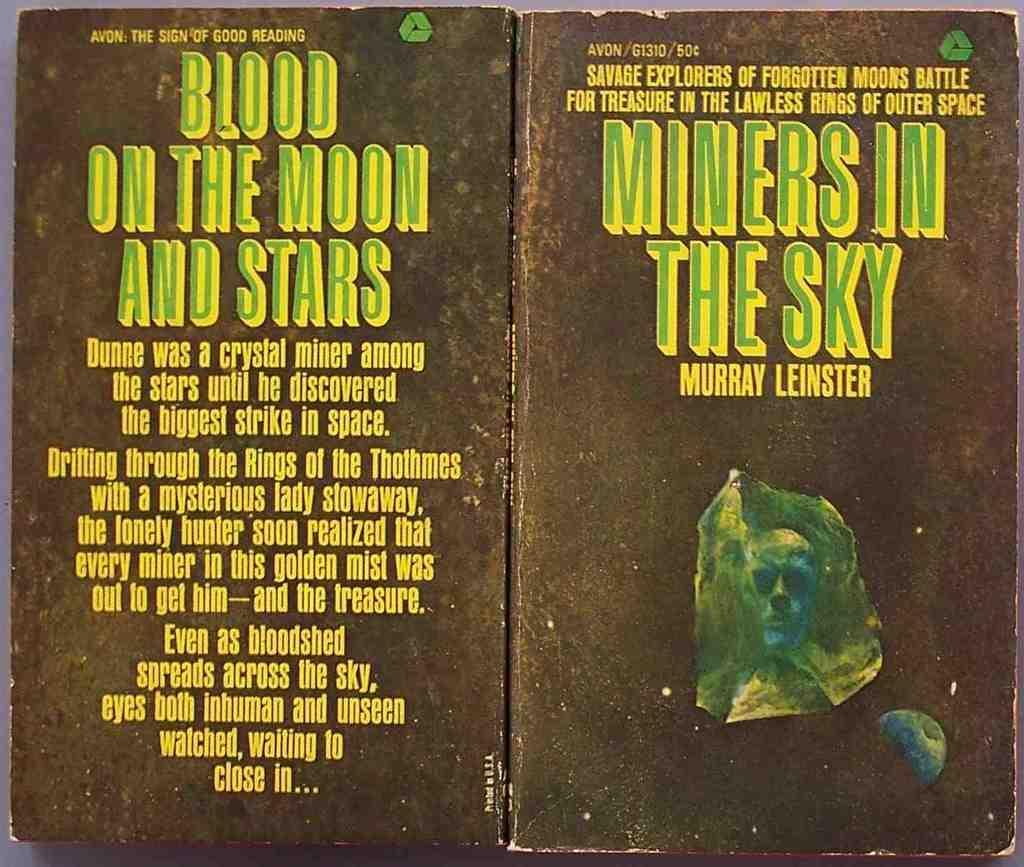<image>
Present a compact description of the photo's key features. A copy of the book Miners in the Sky looks a bit worn. 